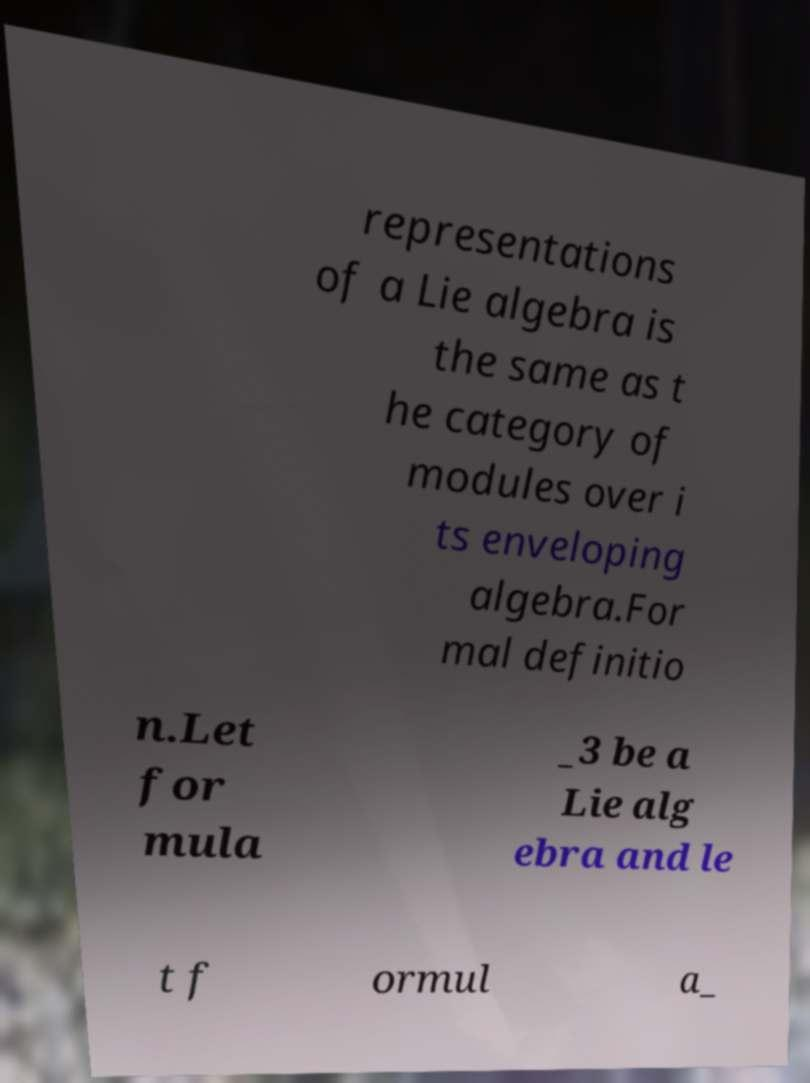Please identify and transcribe the text found in this image. representations of a Lie algebra is the same as t he category of modules over i ts enveloping algebra.For mal definitio n.Let for mula _3 be a Lie alg ebra and le t f ormul a_ 